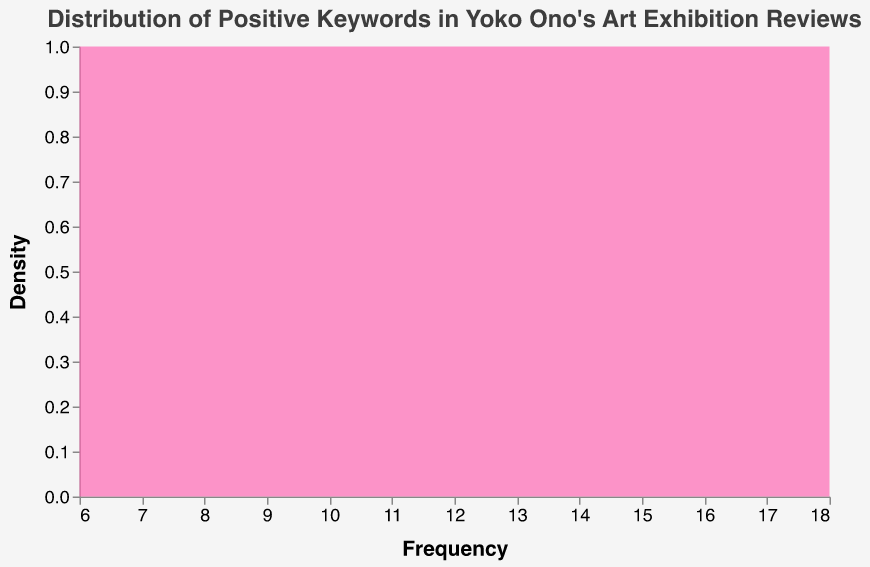What's the title of the plot? The title of the plot is usually the text at the top that describes what the plot is about. In this case, the text at the top says "Distribution of Positive Keywords in Yoko Ono's Art Exhibition Reviews".
Answer: Distribution of Positive Keywords in Yoko Ono's Art Exhibition Reviews What does the x-axis represent? The x-axis label usually tells us what the horizontal axis represents. Here, it is labeled "Frequency". This means it represents how often certain keywords appeared in reviews.
Answer: Frequency What does the y-axis represent? The y-axis label usually tells us what the vertical axis represents. Here, it is labeled "Density". This means it represents the distribution density of the keyword frequencies.
Answer: Density What is the range of frequencies covered in this plot? To find the range, look at the minimum and maximum values on the x-axis, which is labeled "Frequency." The minimum value is 6 and the maximum value is 18, according to the data provided.
Answer: 6 to 18 Which keyword has the highest frequency in Yoko Ono's art exhibition reviews? The keyword with the highest frequency can be identified by looking at the peak value in the data. According to the provided data, "Inspirational" has the highest frequency of 18.
Answer: Inspirational What is the frequency of the least common keyword? The least common keyword is identified by the minimum frequency value in the data. According to the data, "Bold" has the lowest frequency of 6.
Answer: 6 How many keywords have a frequency greater than 10? To answer this, count all the keywords in the data with a frequency greater than 10. These keywords are "Captivating", "Thought-provoking", "Inspirational", "Visionary", "Emotional", and "Unique", making a total of 6.
Answer: 6 Is the keyword "Captivating" one of the top three most frequent keywords? To determine whether "Captivating" is in the top three, we need to compare its frequency with others: "Inspirational" (18), "Captivating" (15), and "Visionary" (14) are the three highest frequencies according to the data. Yes, "Captivating" has 15 counts and is the second-highest.
Answer: Yes What is the median frequency of all keywords? To find the median, list all frequencies in ascending order and find the middle value. The sorted frequencies are: 6, 7, 8, 9, 10, 11, 12, 13, 14, 15, 18. The median is the sixth value in this list.
Answer: 11 Based on the density plot, would you consider the keyword distribution to be narrow or wide, and why? By examining the spread along the x-axis (frequency) and the density on the y-axis, if we see most frequencies are clustered tightly, the distribution is narrow; if spread out, it's wide. Here, the frequencies range from 6 to 18 but are relatively close, suggesting a narrow distribution.
Answer: Narrow 